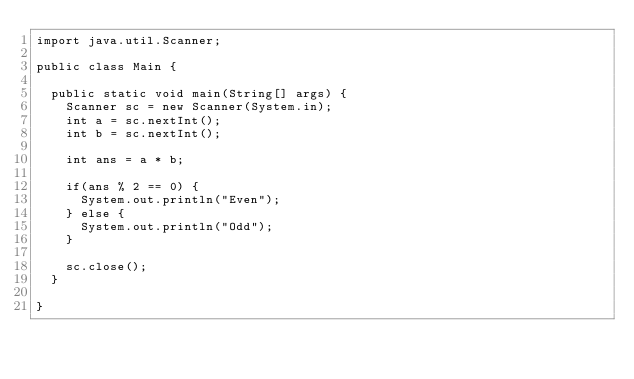<code> <loc_0><loc_0><loc_500><loc_500><_Java_>import java.util.Scanner;

public class Main {

	public static void main(String[] args) {
		Scanner sc = new Scanner(System.in);
		int a = sc.nextInt();
		int b = sc.nextInt();
		
		int ans = a * b;
		
		if(ans % 2 == 0) {
			System.out.println("Even");
		} else {
			System.out.println("Odd");
		}
		
		sc.close();
	}

}
</code> 